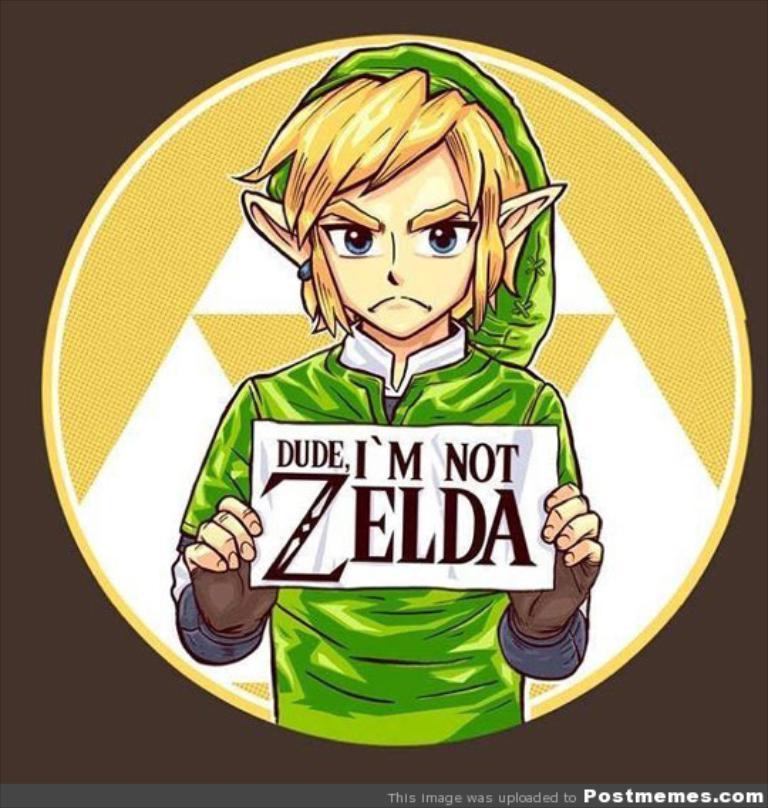Is he zelda?
Make the answer very short. No. Who is this character not?
Offer a terse response. Zelda. 